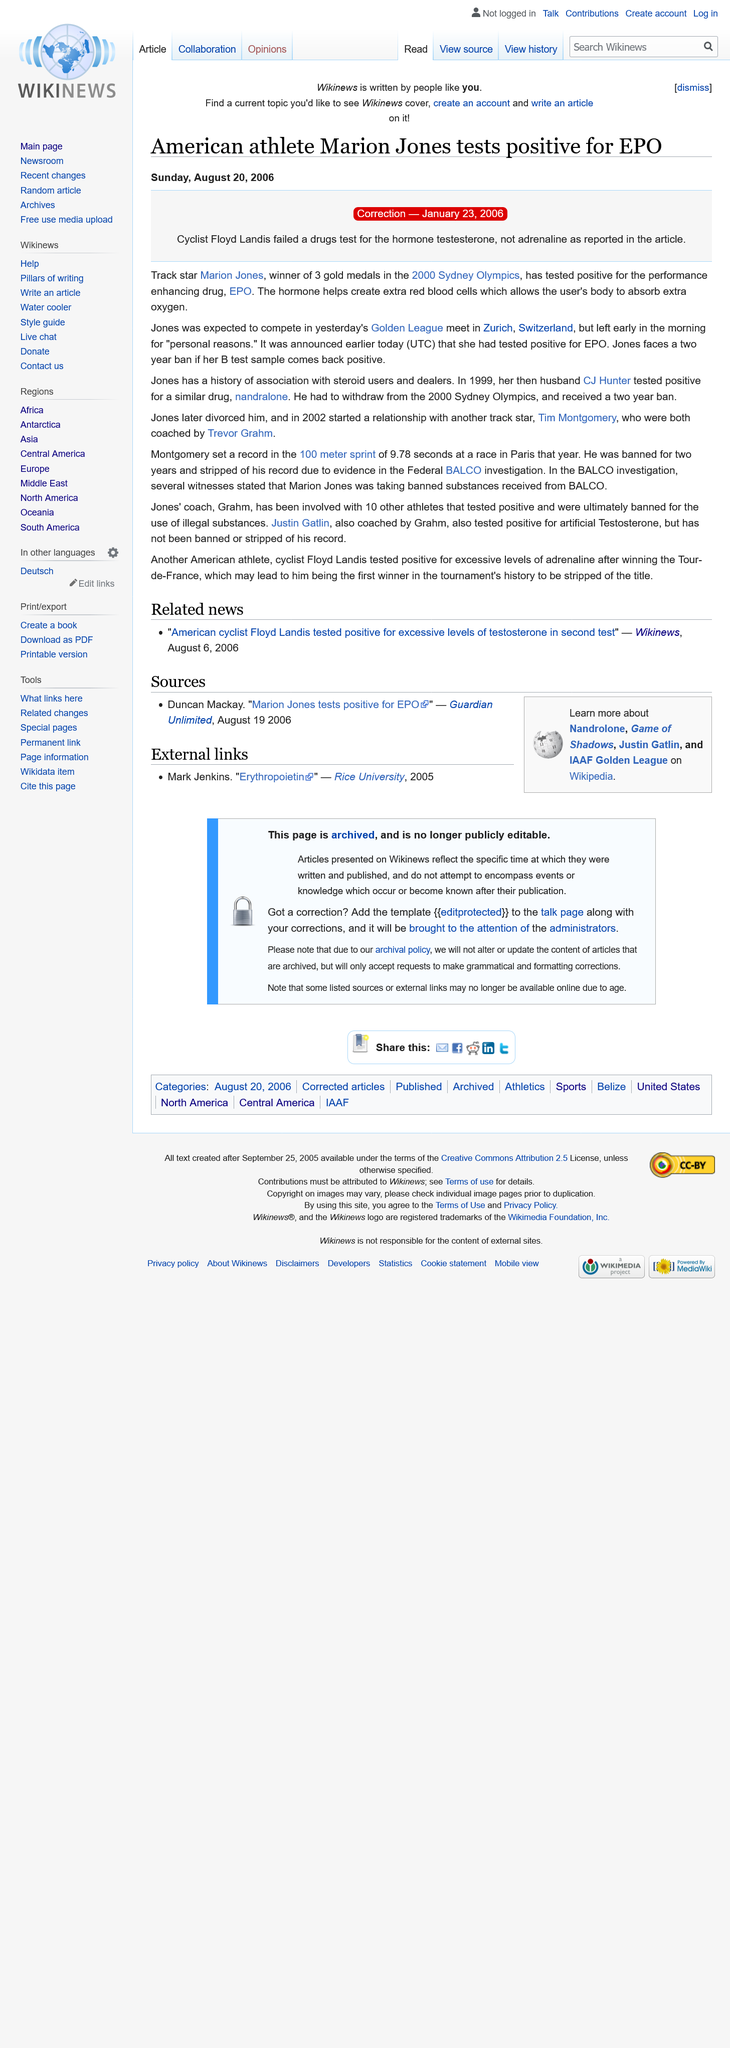Draw attention to some important aspects in this diagram. The article was written on Sunday, August 20, 2006. Floyd Landis, a renowned cyclist, and Marion Jones, a successful track star, were mentioned in the article as accomplished athletes. The article mentions two cities: Sydney and Zurich. 